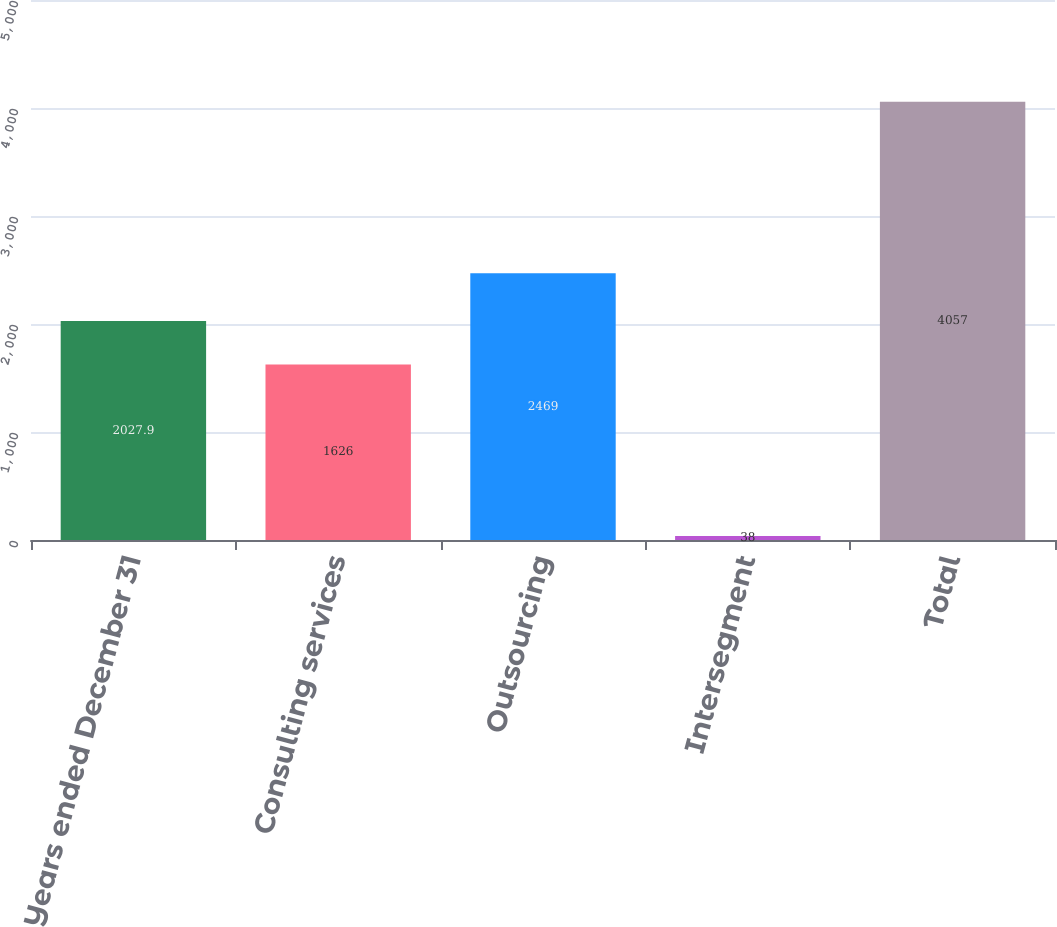Convert chart. <chart><loc_0><loc_0><loc_500><loc_500><bar_chart><fcel>Years ended December 31<fcel>Consulting services<fcel>Outsourcing<fcel>Intersegment<fcel>Total<nl><fcel>2027.9<fcel>1626<fcel>2469<fcel>38<fcel>4057<nl></chart> 